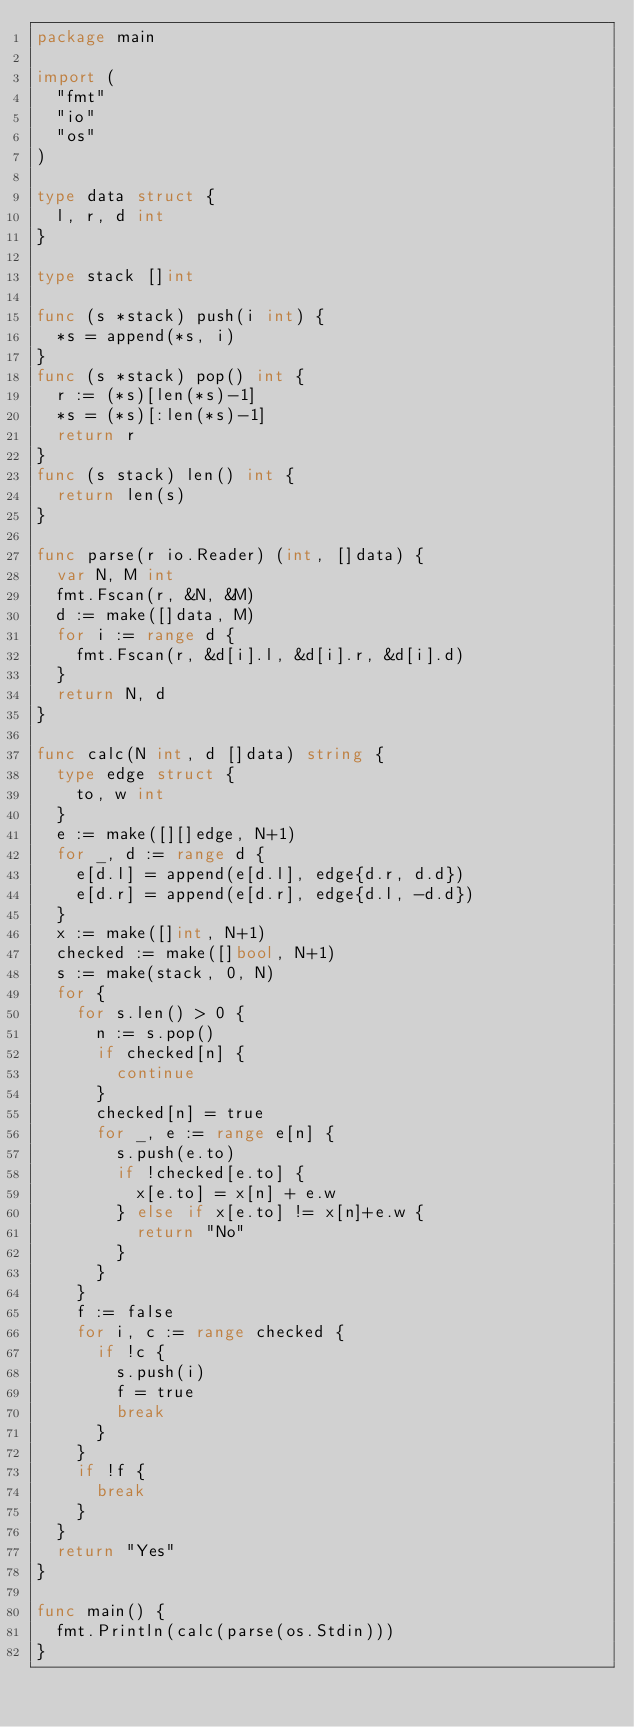Convert code to text. <code><loc_0><loc_0><loc_500><loc_500><_Go_>package main

import (
	"fmt"
	"io"
	"os"
)

type data struct {
	l, r, d int
}

type stack []int

func (s *stack) push(i int) {
	*s = append(*s, i)
}
func (s *stack) pop() int {
	r := (*s)[len(*s)-1]
	*s = (*s)[:len(*s)-1]
	return r
}
func (s stack) len() int {
	return len(s)
}

func parse(r io.Reader) (int, []data) {
	var N, M int
	fmt.Fscan(r, &N, &M)
	d := make([]data, M)
	for i := range d {
		fmt.Fscan(r, &d[i].l, &d[i].r, &d[i].d)
	}
	return N, d
}

func calc(N int, d []data) string {
	type edge struct {
		to, w int
	}
	e := make([][]edge, N+1)
	for _, d := range d {
		e[d.l] = append(e[d.l], edge{d.r, d.d})
		e[d.r] = append(e[d.r], edge{d.l, -d.d})
	}
	x := make([]int, N+1)
	checked := make([]bool, N+1)
	s := make(stack, 0, N)
	for {
		for s.len() > 0 {
			n := s.pop()
			if checked[n] {
				continue
			}
			checked[n] = true
			for _, e := range e[n] {
				s.push(e.to)
				if !checked[e.to] {
					x[e.to] = x[n] + e.w
				} else if x[e.to] != x[n]+e.w {
					return "No"
				}
			}
		}
		f := false
		for i, c := range checked {
			if !c {
				s.push(i)
				f = true
				break
			}
		}
		if !f {
			break
		}
	}
	return "Yes"
}

func main() {
	fmt.Println(calc(parse(os.Stdin)))
}
</code> 